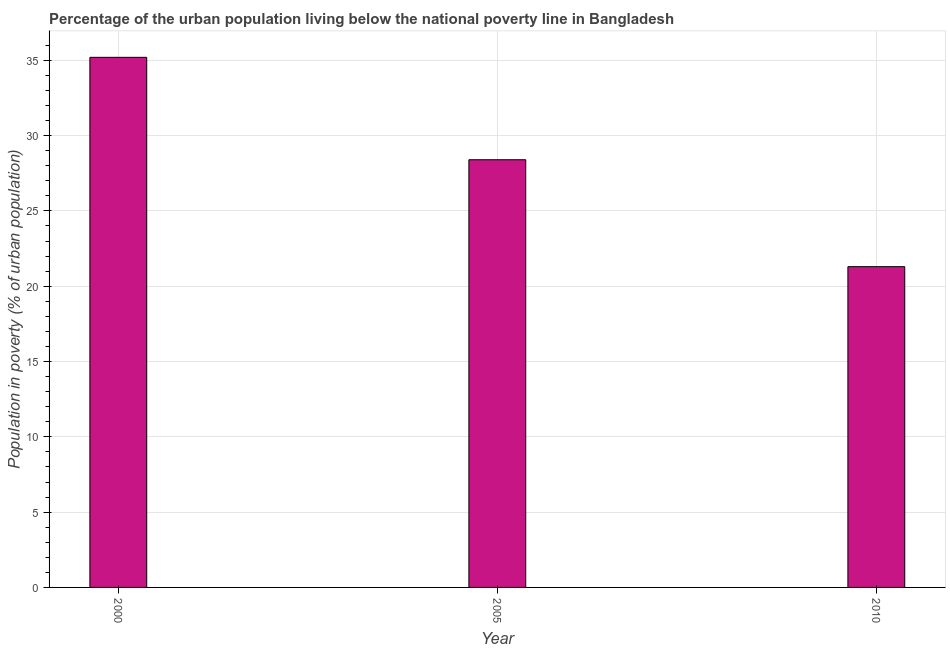Does the graph contain grids?
Provide a short and direct response. Yes. What is the title of the graph?
Your answer should be compact. Percentage of the urban population living below the national poverty line in Bangladesh. What is the label or title of the X-axis?
Provide a succinct answer. Year. What is the label or title of the Y-axis?
Offer a terse response. Population in poverty (% of urban population). What is the percentage of urban population living below poverty line in 2000?
Offer a very short reply. 35.2. Across all years, what is the maximum percentage of urban population living below poverty line?
Provide a short and direct response. 35.2. Across all years, what is the minimum percentage of urban population living below poverty line?
Offer a very short reply. 21.3. In which year was the percentage of urban population living below poverty line maximum?
Give a very brief answer. 2000. In which year was the percentage of urban population living below poverty line minimum?
Offer a very short reply. 2010. What is the sum of the percentage of urban population living below poverty line?
Ensure brevity in your answer.  84.9. What is the average percentage of urban population living below poverty line per year?
Ensure brevity in your answer.  28.3. What is the median percentage of urban population living below poverty line?
Offer a terse response. 28.4. In how many years, is the percentage of urban population living below poverty line greater than 4 %?
Provide a succinct answer. 3. Do a majority of the years between 2000 and 2010 (inclusive) have percentage of urban population living below poverty line greater than 24 %?
Offer a very short reply. Yes. What is the ratio of the percentage of urban population living below poverty line in 2000 to that in 2010?
Provide a succinct answer. 1.65. Are all the bars in the graph horizontal?
Keep it short and to the point. No. How many years are there in the graph?
Give a very brief answer. 3. What is the difference between two consecutive major ticks on the Y-axis?
Offer a terse response. 5. What is the Population in poverty (% of urban population) in 2000?
Offer a terse response. 35.2. What is the Population in poverty (% of urban population) in 2005?
Provide a succinct answer. 28.4. What is the Population in poverty (% of urban population) of 2010?
Your response must be concise. 21.3. What is the difference between the Population in poverty (% of urban population) in 2000 and 2005?
Make the answer very short. 6.8. What is the difference between the Population in poverty (% of urban population) in 2000 and 2010?
Offer a terse response. 13.9. What is the difference between the Population in poverty (% of urban population) in 2005 and 2010?
Make the answer very short. 7.1. What is the ratio of the Population in poverty (% of urban population) in 2000 to that in 2005?
Offer a terse response. 1.24. What is the ratio of the Population in poverty (% of urban population) in 2000 to that in 2010?
Ensure brevity in your answer.  1.65. What is the ratio of the Population in poverty (% of urban population) in 2005 to that in 2010?
Give a very brief answer. 1.33. 